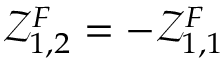Convert formula to latex. <formula><loc_0><loc_0><loc_500><loc_500>\mathcal { Z } _ { 1 , 2 } ^ { F } = - \mathcal { Z } _ { 1 , 1 } ^ { F }</formula> 